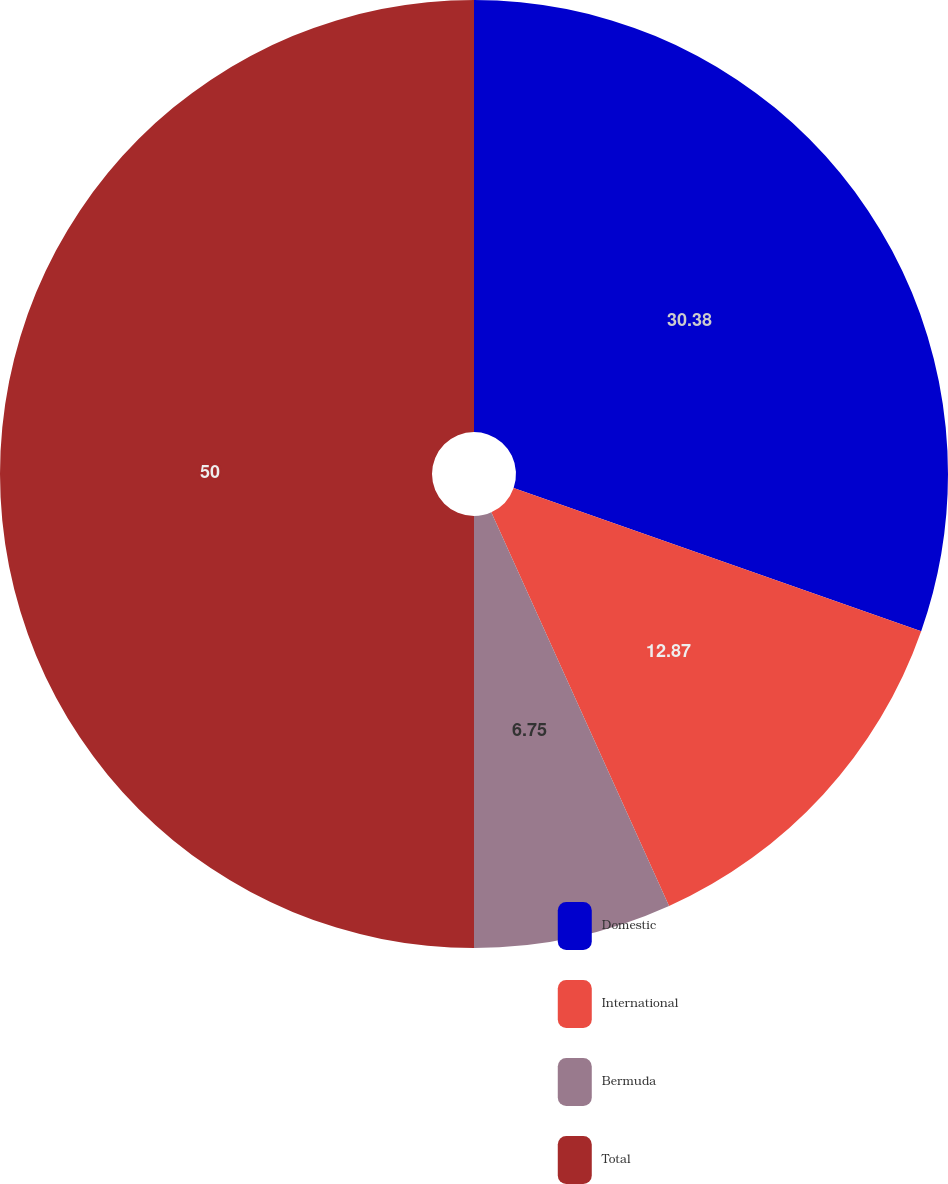Convert chart. <chart><loc_0><loc_0><loc_500><loc_500><pie_chart><fcel>Domestic<fcel>International<fcel>Bermuda<fcel>Total<nl><fcel>30.38%<fcel>12.87%<fcel>6.75%<fcel>50.0%<nl></chart> 